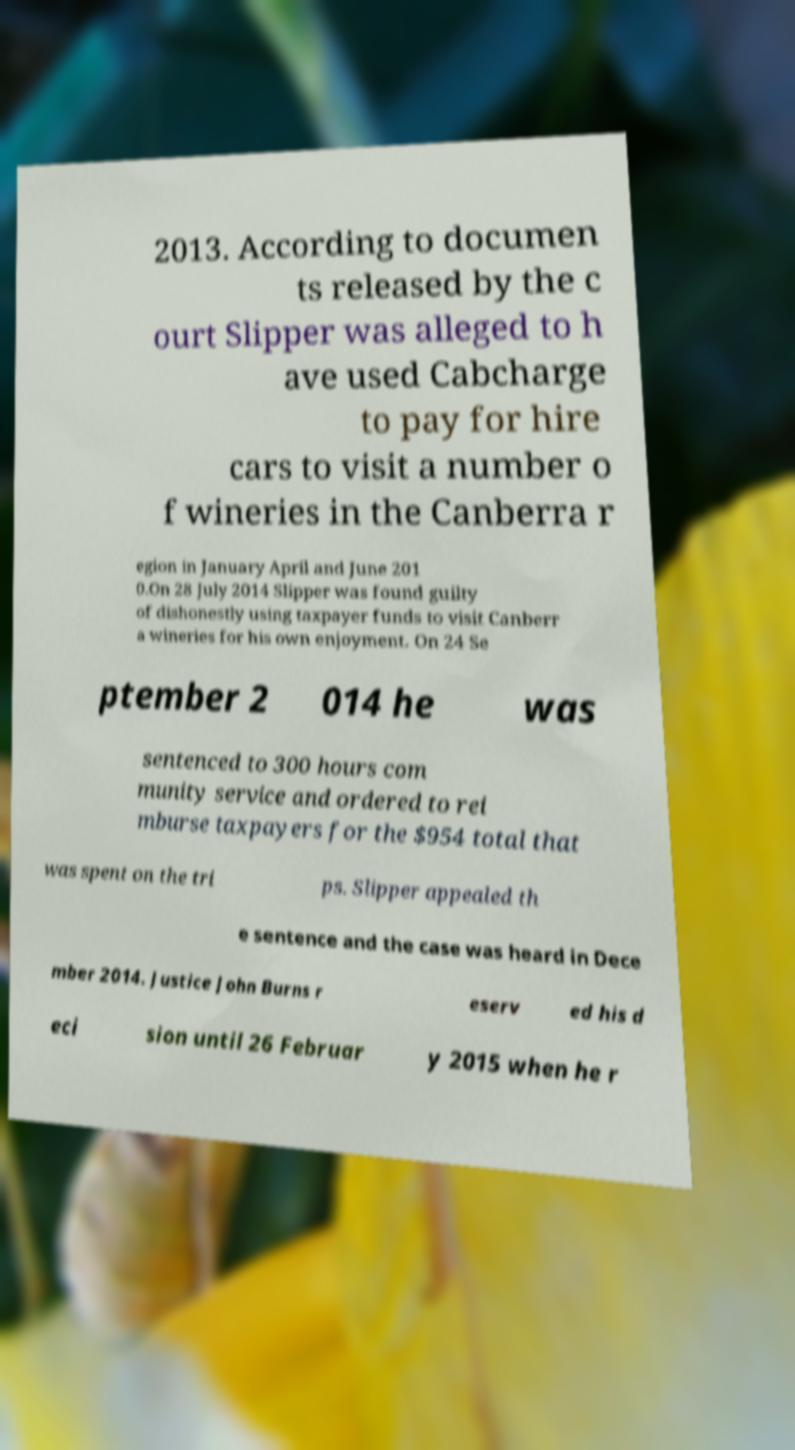I need the written content from this picture converted into text. Can you do that? 2013. According to documen ts released by the c ourt Slipper was alleged to h ave used Cabcharge to pay for hire cars to visit a number o f wineries in the Canberra r egion in January April and June 201 0.On 28 July 2014 Slipper was found guilty of dishonestly using taxpayer funds to visit Canberr a wineries for his own enjoyment. On 24 Se ptember 2 014 he was sentenced to 300 hours com munity service and ordered to rei mburse taxpayers for the $954 total that was spent on the tri ps. Slipper appealed th e sentence and the case was heard in Dece mber 2014. Justice John Burns r eserv ed his d eci sion until 26 Februar y 2015 when he r 